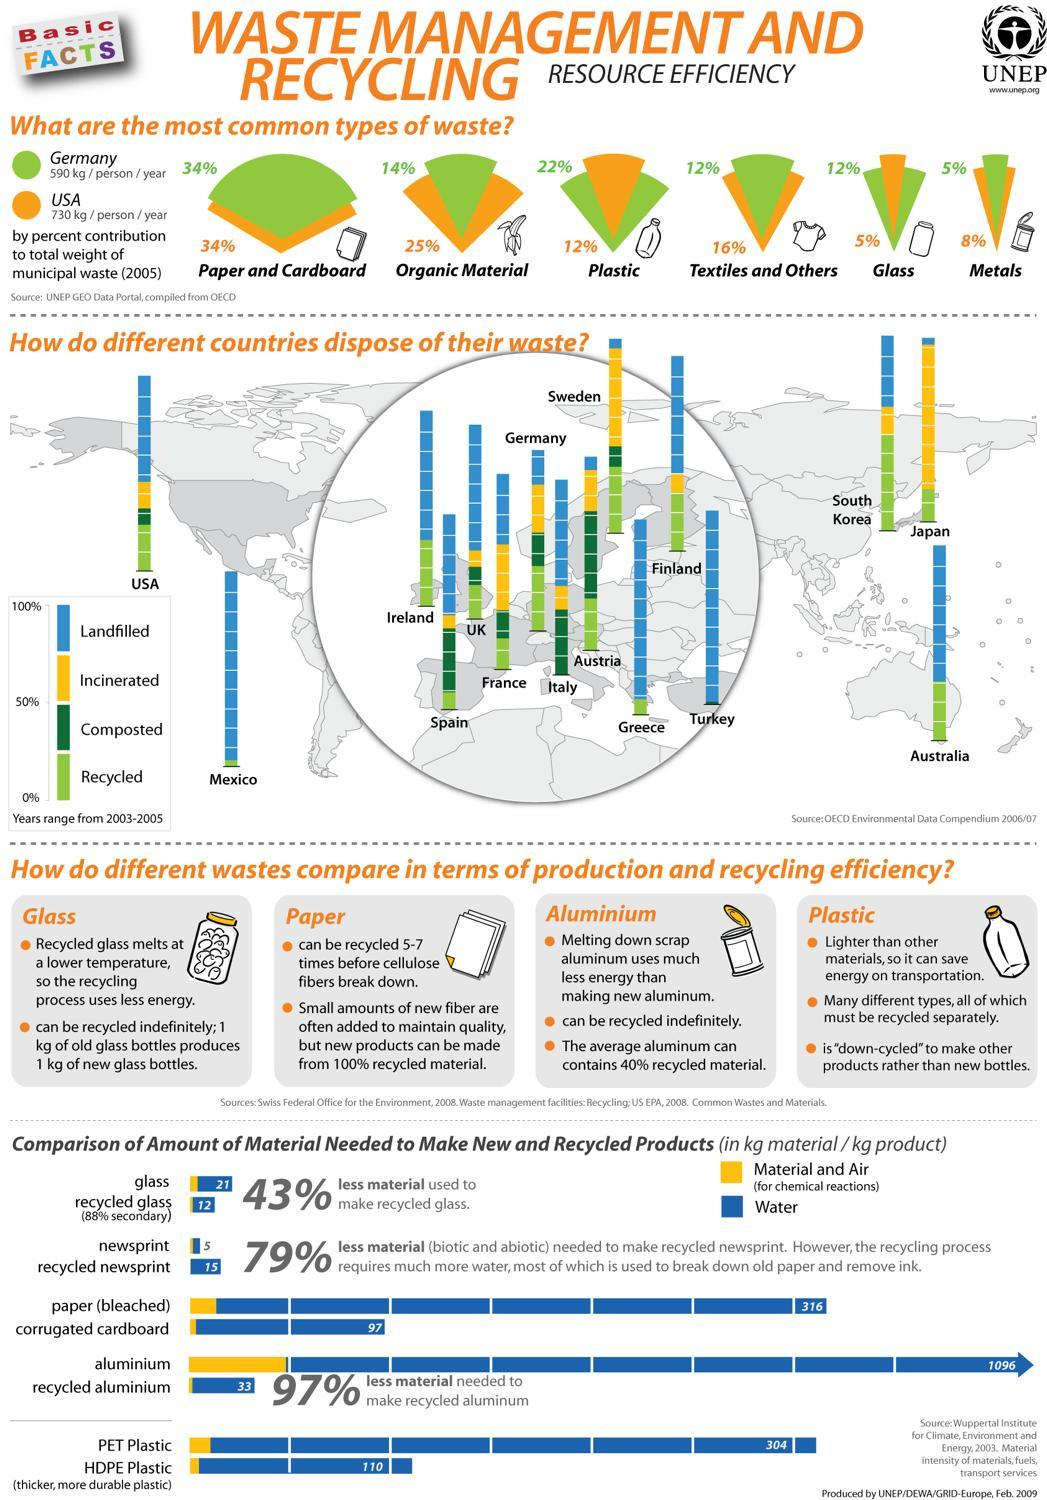Which material requires the least amount of material to recycle it, glass, newsprint, plastic, or Aluminium?
Answer the question with a short phrase. Aluminium How many countries do not incinerate any waste? 5 Which country generate more organic wastes, Germany or USA? USA Which country has the highest percentage of composted waste? Austria Which country has a lower percentage of plastic waste? USA What is the percentage of paper and cardboard in the waste generated by the US and Germany? 34% Which country least amount of landfilled waste? Japan Which country does not recycle any waste? Turkey What is the percentage of textiles and glass waste is generated by Germany? 12% 